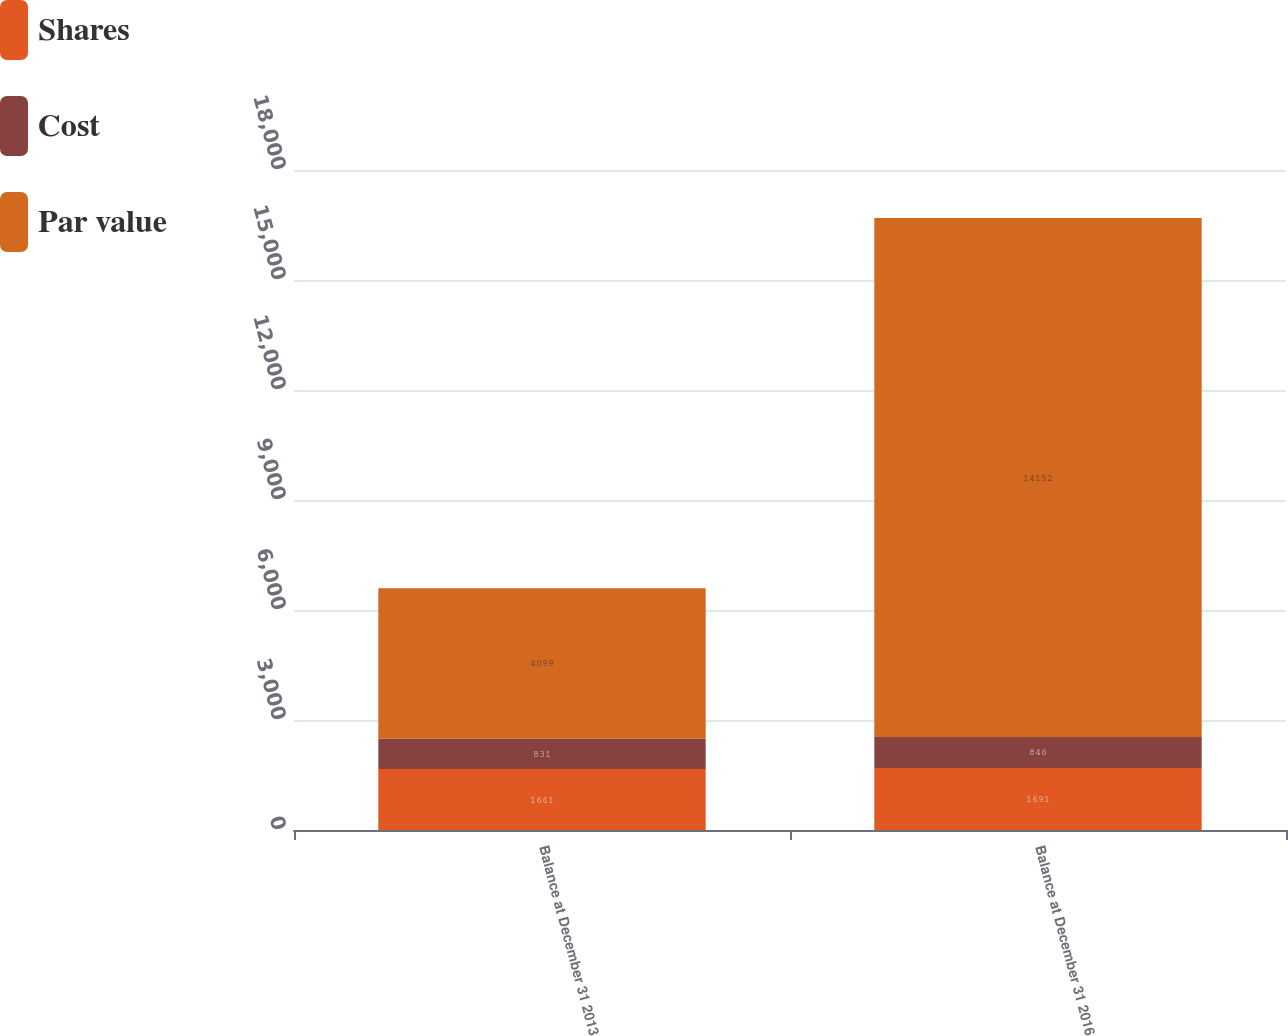<chart> <loc_0><loc_0><loc_500><loc_500><stacked_bar_chart><ecel><fcel>Balance at December 31 2013<fcel>Balance at December 31 2016<nl><fcel>Shares<fcel>1661<fcel>1691<nl><fcel>Cost<fcel>831<fcel>846<nl><fcel>Par value<fcel>4099<fcel>14152<nl></chart> 